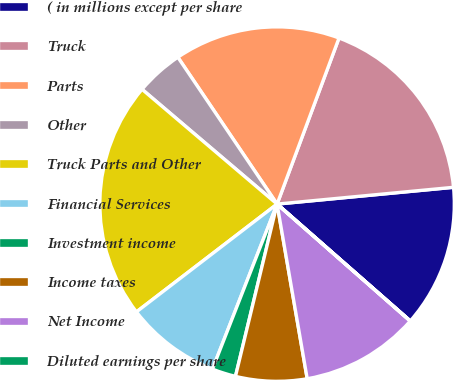<chart> <loc_0><loc_0><loc_500><loc_500><pie_chart><fcel>( in millions except per share<fcel>Truck<fcel>Parts<fcel>Other<fcel>Truck Parts and Other<fcel>Financial Services<fcel>Investment income<fcel>Income taxes<fcel>Net Income<fcel>Diluted earnings per share<nl><fcel>12.97%<fcel>17.81%<fcel>15.14%<fcel>4.33%<fcel>21.62%<fcel>8.65%<fcel>2.17%<fcel>6.49%<fcel>10.81%<fcel>0.01%<nl></chart> 